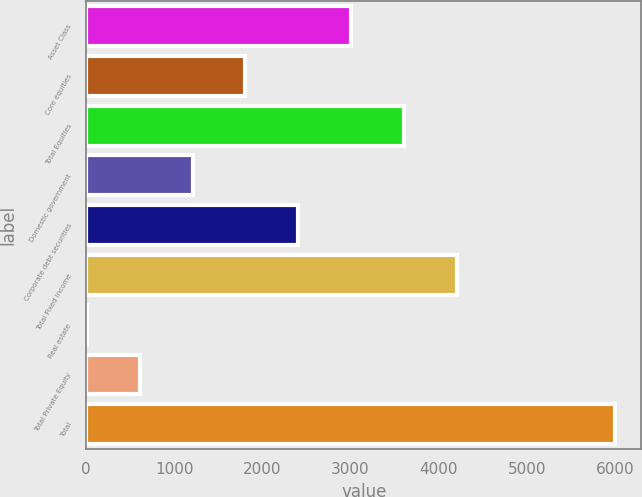Convert chart to OTSL. <chart><loc_0><loc_0><loc_500><loc_500><bar_chart><fcel>Asset Class<fcel>Core equities<fcel>Total Equities<fcel>Domestic government<fcel>Corporate debt securities<fcel>Total Fixed Income<fcel>Real estate<fcel>Total Private Equity<fcel>Total<nl><fcel>3005<fcel>1807.8<fcel>3603.6<fcel>1209.2<fcel>2406.4<fcel>4202.2<fcel>12<fcel>610.6<fcel>5998<nl></chart> 